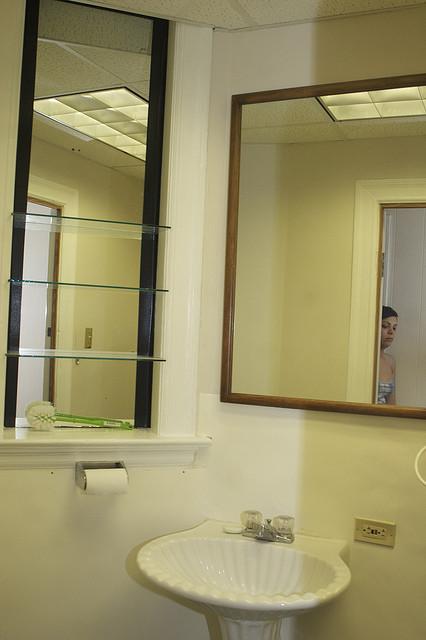What is open in this picture?
Be succinct. Door. Is it a bath or a shower?
Give a very brief answer. Neither. What room is this?
Concise answer only. Bathroom. Where is the bowl brush?
Give a very brief answer. Shelf. Which direction is the outlet?
Be succinct. Horizontal. Are there any human in this picture?
Short answer required. Yes. How many sinks are here?
Quick response, please. 1. What color is the frame of the mirror?
Be succinct. Brown. 